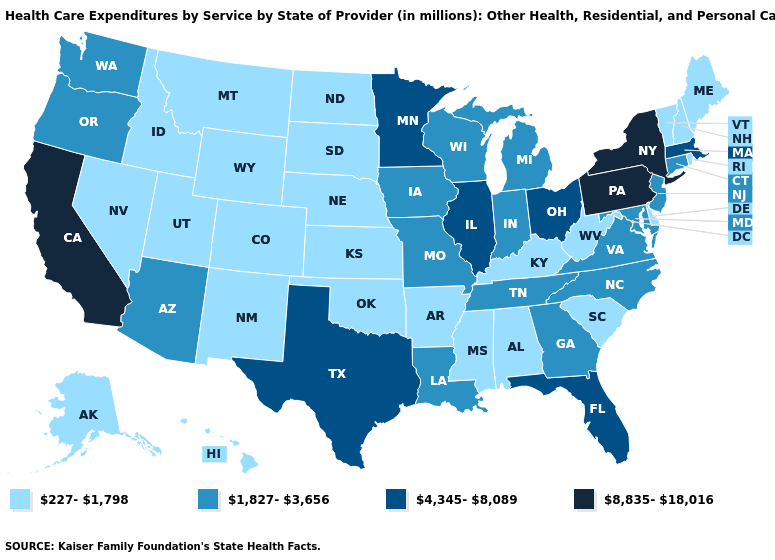What is the value of New Jersey?
Short answer required. 1,827-3,656. What is the value of Arkansas?
Give a very brief answer. 227-1,798. What is the highest value in the USA?
Quick response, please. 8,835-18,016. What is the value of New Jersey?
Be succinct. 1,827-3,656. What is the lowest value in states that border Utah?
Write a very short answer. 227-1,798. Name the states that have a value in the range 4,345-8,089?
Answer briefly. Florida, Illinois, Massachusetts, Minnesota, Ohio, Texas. Does Washington have a lower value than Ohio?
Give a very brief answer. Yes. Name the states that have a value in the range 227-1,798?
Short answer required. Alabama, Alaska, Arkansas, Colorado, Delaware, Hawaii, Idaho, Kansas, Kentucky, Maine, Mississippi, Montana, Nebraska, Nevada, New Hampshire, New Mexico, North Dakota, Oklahoma, Rhode Island, South Carolina, South Dakota, Utah, Vermont, West Virginia, Wyoming. Does Kentucky have a lower value than Louisiana?
Quick response, please. Yes. Name the states that have a value in the range 8,835-18,016?
Quick response, please. California, New York, Pennsylvania. Does California have the highest value in the West?
Be succinct. Yes. What is the lowest value in the USA?
Concise answer only. 227-1,798. Does California have a higher value than Pennsylvania?
Quick response, please. No. What is the highest value in the USA?
Quick response, please. 8,835-18,016. How many symbols are there in the legend?
Answer briefly. 4. 